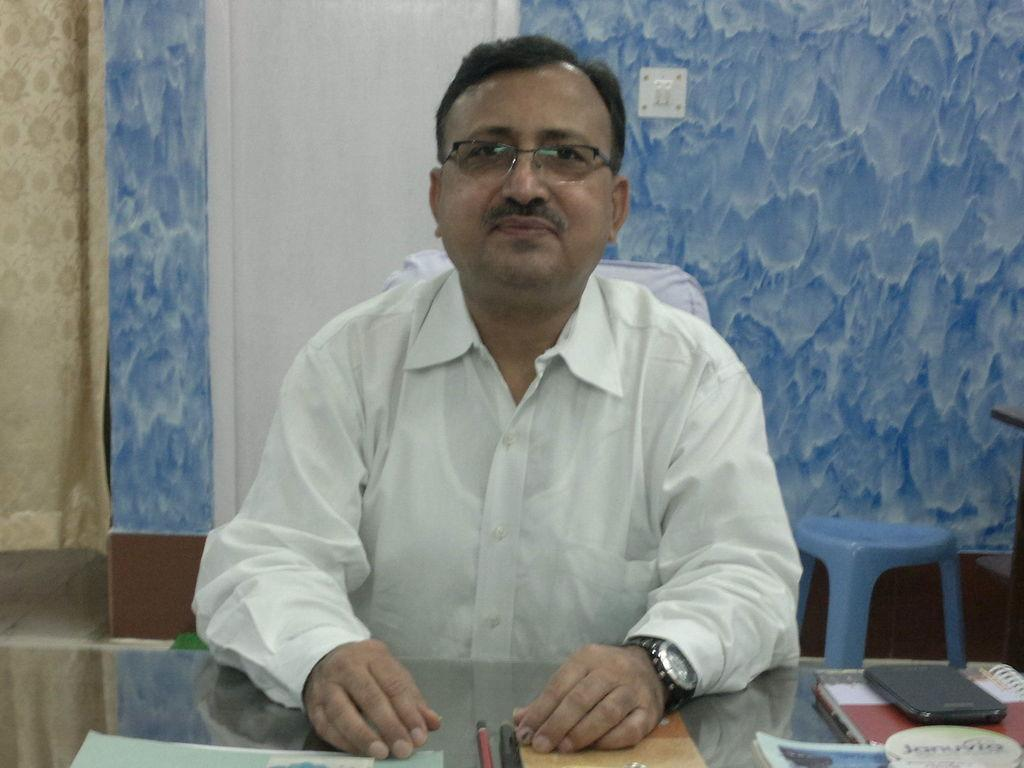What is the man in the image doing? The man is sitting on a chair in the image. What can be seen on the wall in the image? There is a switch board on the wall in the image. What type of seating is present in the image besides the chair? There is a blue color stool in the image. What is on the table in the image? There is a pencil, a book, and a mobile phone on the table in the image. What type of thunder can be heard in the image? There is no thunder present in the image, as it is a still image and not an audio recording. 